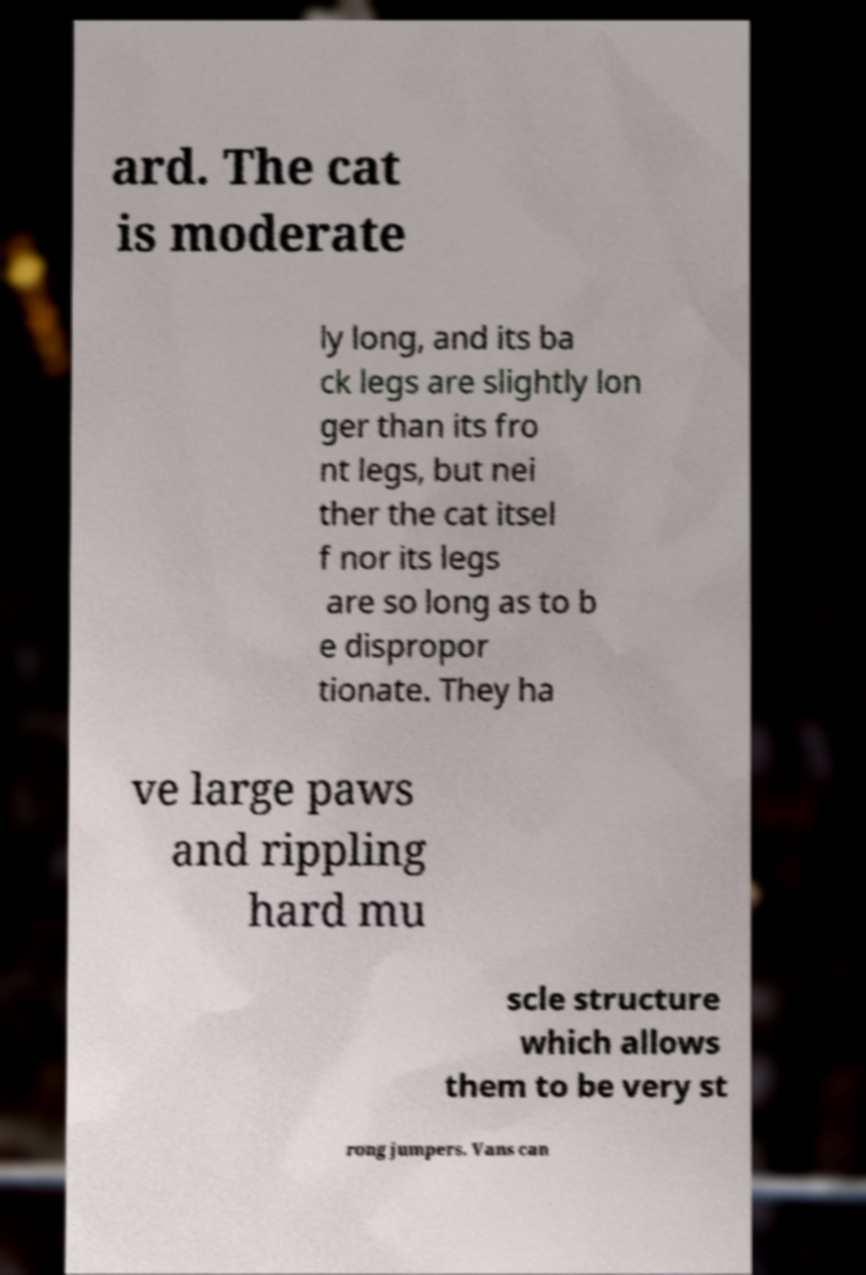What messages or text are displayed in this image? I need them in a readable, typed format. ard. The cat is moderate ly long, and its ba ck legs are slightly lon ger than its fro nt legs, but nei ther the cat itsel f nor its legs are so long as to b e dispropor tionate. They ha ve large paws and rippling hard mu scle structure which allows them to be very st rong jumpers. Vans can 